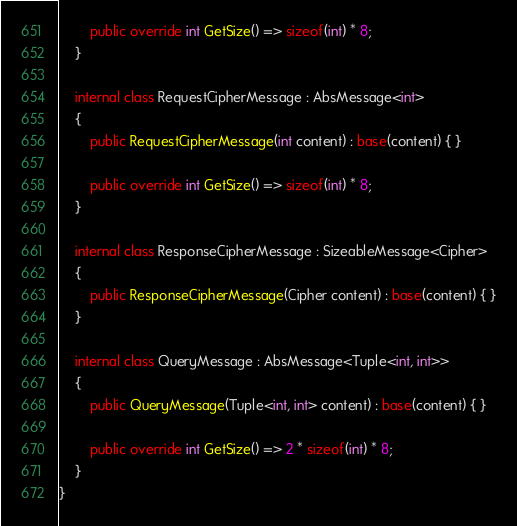Convert code to text. <code><loc_0><loc_0><loc_500><loc_500><_C#_>		public override int GetSize() => sizeof(int) * 8;
	}

	internal class RequestCipherMessage : AbsMessage<int>
	{
		public RequestCipherMessage(int content) : base(content) { }

		public override int GetSize() => sizeof(int) * 8;
	}

	internal class ResponseCipherMessage : SizeableMessage<Cipher>
	{
		public ResponseCipherMessage(Cipher content) : base(content) { }
	}

	internal class QueryMessage : AbsMessage<Tuple<int, int>>
	{
		public QueryMessage(Tuple<int, int> content) : base(content) { }

		public override int GetSize() => 2 * sizeof(int) * 8;
	}
}
</code> 